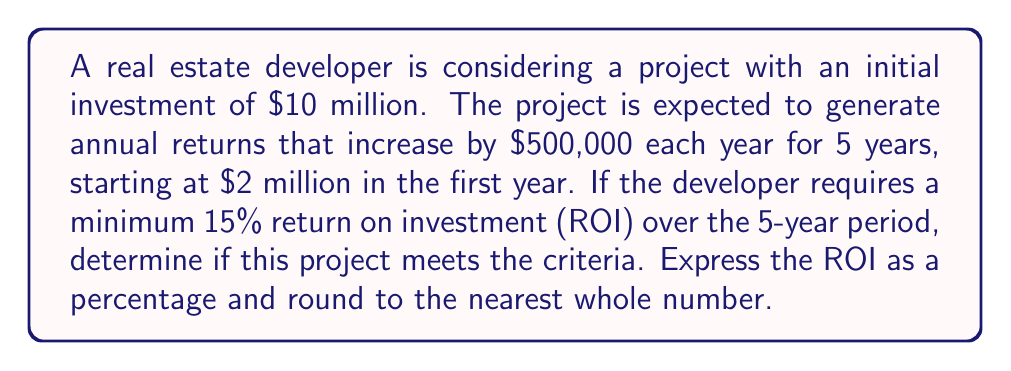Provide a solution to this math problem. Let's approach this step-by-step:

1) First, calculate the total returns over 5 years:
   Year 1: $2,000,000
   Year 2: $2,500,000
   Year 3: $3,000,000
   Year 4: $3,500,000
   Year 5: $4,000,000

   Total returns = $15,000,000

2) Calculate the net profit:
   Net profit = Total returns - Initial investment
   $$ \text{Net profit} = \$15,000,000 - \$10,000,000 = \$5,000,000 $$

3) Calculate the ROI:
   $$ \text{ROI} = \frac{\text{Net profit}}{\text{Initial investment}} \times 100\% $$
   $$ \text{ROI} = \frac{\$5,000,000}{\$10,000,000} \times 100\% = 50\% $$

4) Compare the calculated ROI to the required minimum:
   Calculated ROI (50%) > Required minimum ROI (15%)

5) Round the ROI to the nearest whole number:
   50% (already a whole number)

Therefore, the project meets the criteria as it exceeds the minimum required ROI.
Answer: 50% 